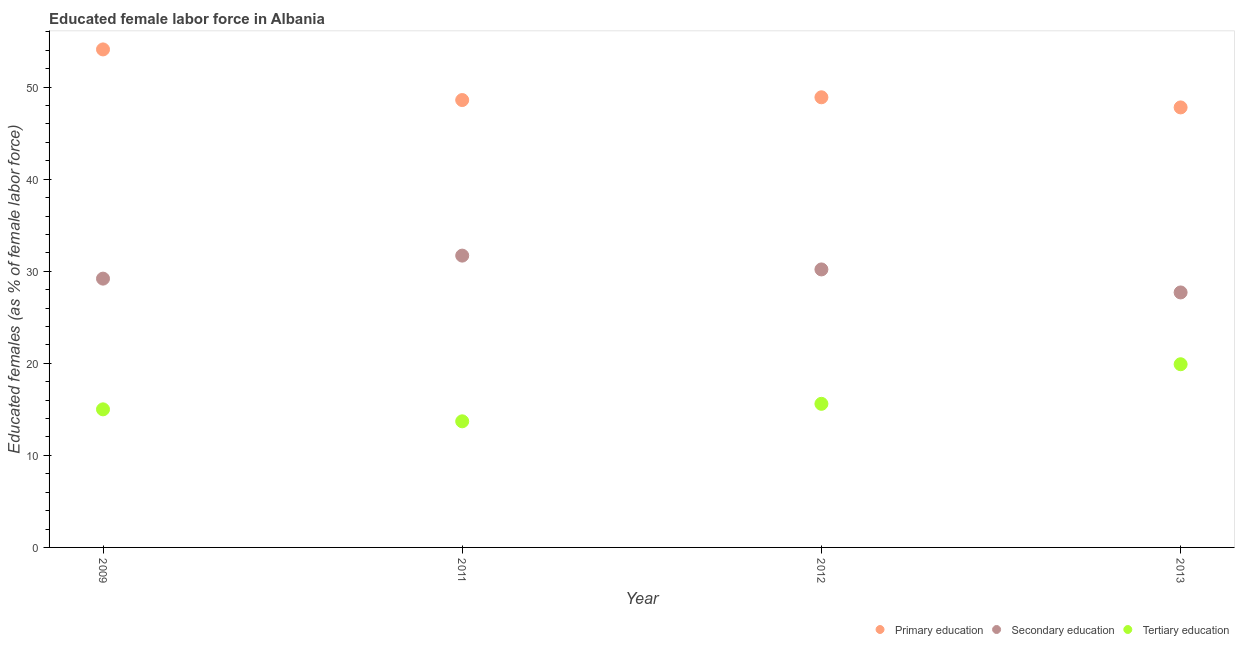What is the percentage of female labor force who received secondary education in 2012?
Provide a succinct answer. 30.2. Across all years, what is the maximum percentage of female labor force who received tertiary education?
Your response must be concise. 19.9. Across all years, what is the minimum percentage of female labor force who received primary education?
Offer a terse response. 47.8. In which year was the percentage of female labor force who received tertiary education maximum?
Your response must be concise. 2013. What is the total percentage of female labor force who received primary education in the graph?
Keep it short and to the point. 199.4. What is the difference between the percentage of female labor force who received tertiary education in 2011 and that in 2012?
Your answer should be compact. -1.9. What is the difference between the percentage of female labor force who received tertiary education in 2011 and the percentage of female labor force who received secondary education in 2009?
Ensure brevity in your answer.  -15.5. What is the average percentage of female labor force who received primary education per year?
Your response must be concise. 49.85. In the year 2013, what is the difference between the percentage of female labor force who received secondary education and percentage of female labor force who received primary education?
Offer a terse response. -20.1. What is the ratio of the percentage of female labor force who received primary education in 2009 to that in 2013?
Offer a terse response. 1.13. Is the percentage of female labor force who received secondary education in 2009 less than that in 2012?
Make the answer very short. Yes. Is the difference between the percentage of female labor force who received primary education in 2009 and 2012 greater than the difference between the percentage of female labor force who received secondary education in 2009 and 2012?
Make the answer very short. Yes. What is the difference between the highest and the lowest percentage of female labor force who received tertiary education?
Your response must be concise. 6.2. Is the sum of the percentage of female labor force who received tertiary education in 2009 and 2013 greater than the maximum percentage of female labor force who received primary education across all years?
Your answer should be very brief. No. Does the percentage of female labor force who received primary education monotonically increase over the years?
Your answer should be compact. No. Is the percentage of female labor force who received secondary education strictly greater than the percentage of female labor force who received primary education over the years?
Offer a very short reply. No. What is the difference between two consecutive major ticks on the Y-axis?
Provide a succinct answer. 10. Does the graph contain grids?
Ensure brevity in your answer.  No. Where does the legend appear in the graph?
Your answer should be very brief. Bottom right. How are the legend labels stacked?
Provide a succinct answer. Horizontal. What is the title of the graph?
Your answer should be very brief. Educated female labor force in Albania. What is the label or title of the X-axis?
Ensure brevity in your answer.  Year. What is the label or title of the Y-axis?
Your response must be concise. Educated females (as % of female labor force). What is the Educated females (as % of female labor force) of Primary education in 2009?
Offer a terse response. 54.1. What is the Educated females (as % of female labor force) in Secondary education in 2009?
Provide a succinct answer. 29.2. What is the Educated females (as % of female labor force) of Tertiary education in 2009?
Keep it short and to the point. 15. What is the Educated females (as % of female labor force) in Primary education in 2011?
Keep it short and to the point. 48.6. What is the Educated females (as % of female labor force) in Secondary education in 2011?
Offer a very short reply. 31.7. What is the Educated females (as % of female labor force) in Tertiary education in 2011?
Keep it short and to the point. 13.7. What is the Educated females (as % of female labor force) in Primary education in 2012?
Make the answer very short. 48.9. What is the Educated females (as % of female labor force) in Secondary education in 2012?
Give a very brief answer. 30.2. What is the Educated females (as % of female labor force) of Tertiary education in 2012?
Make the answer very short. 15.6. What is the Educated females (as % of female labor force) in Primary education in 2013?
Your answer should be very brief. 47.8. What is the Educated females (as % of female labor force) in Secondary education in 2013?
Ensure brevity in your answer.  27.7. What is the Educated females (as % of female labor force) in Tertiary education in 2013?
Provide a short and direct response. 19.9. Across all years, what is the maximum Educated females (as % of female labor force) in Primary education?
Your response must be concise. 54.1. Across all years, what is the maximum Educated females (as % of female labor force) of Secondary education?
Give a very brief answer. 31.7. Across all years, what is the maximum Educated females (as % of female labor force) in Tertiary education?
Make the answer very short. 19.9. Across all years, what is the minimum Educated females (as % of female labor force) of Primary education?
Make the answer very short. 47.8. Across all years, what is the minimum Educated females (as % of female labor force) in Secondary education?
Offer a very short reply. 27.7. Across all years, what is the minimum Educated females (as % of female labor force) of Tertiary education?
Make the answer very short. 13.7. What is the total Educated females (as % of female labor force) of Primary education in the graph?
Make the answer very short. 199.4. What is the total Educated females (as % of female labor force) of Secondary education in the graph?
Keep it short and to the point. 118.8. What is the total Educated females (as % of female labor force) of Tertiary education in the graph?
Make the answer very short. 64.2. What is the difference between the Educated females (as % of female labor force) of Secondary education in 2009 and that in 2011?
Your response must be concise. -2.5. What is the difference between the Educated females (as % of female labor force) in Secondary education in 2009 and that in 2012?
Offer a terse response. -1. What is the difference between the Educated females (as % of female labor force) of Secondary education in 2009 and that in 2013?
Your answer should be very brief. 1.5. What is the difference between the Educated females (as % of female labor force) of Secondary education in 2011 and that in 2013?
Give a very brief answer. 4. What is the difference between the Educated females (as % of female labor force) of Tertiary education in 2011 and that in 2013?
Your answer should be compact. -6.2. What is the difference between the Educated females (as % of female labor force) of Primary education in 2012 and that in 2013?
Give a very brief answer. 1.1. What is the difference between the Educated females (as % of female labor force) in Primary education in 2009 and the Educated females (as % of female labor force) in Secondary education in 2011?
Offer a terse response. 22.4. What is the difference between the Educated females (as % of female labor force) in Primary education in 2009 and the Educated females (as % of female labor force) in Tertiary education in 2011?
Your response must be concise. 40.4. What is the difference between the Educated females (as % of female labor force) in Secondary education in 2009 and the Educated females (as % of female labor force) in Tertiary education in 2011?
Your response must be concise. 15.5. What is the difference between the Educated females (as % of female labor force) of Primary education in 2009 and the Educated females (as % of female labor force) of Secondary education in 2012?
Make the answer very short. 23.9. What is the difference between the Educated females (as % of female labor force) in Primary education in 2009 and the Educated females (as % of female labor force) in Tertiary education in 2012?
Keep it short and to the point. 38.5. What is the difference between the Educated females (as % of female labor force) in Secondary education in 2009 and the Educated females (as % of female labor force) in Tertiary education in 2012?
Your answer should be compact. 13.6. What is the difference between the Educated females (as % of female labor force) of Primary education in 2009 and the Educated females (as % of female labor force) of Secondary education in 2013?
Keep it short and to the point. 26.4. What is the difference between the Educated females (as % of female labor force) in Primary education in 2009 and the Educated females (as % of female labor force) in Tertiary education in 2013?
Make the answer very short. 34.2. What is the difference between the Educated females (as % of female labor force) in Secondary education in 2009 and the Educated females (as % of female labor force) in Tertiary education in 2013?
Your answer should be very brief. 9.3. What is the difference between the Educated females (as % of female labor force) of Primary education in 2011 and the Educated females (as % of female labor force) of Secondary education in 2013?
Your answer should be very brief. 20.9. What is the difference between the Educated females (as % of female labor force) in Primary education in 2011 and the Educated females (as % of female labor force) in Tertiary education in 2013?
Offer a very short reply. 28.7. What is the difference between the Educated females (as % of female labor force) of Primary education in 2012 and the Educated females (as % of female labor force) of Secondary education in 2013?
Offer a terse response. 21.2. What is the difference between the Educated females (as % of female labor force) in Primary education in 2012 and the Educated females (as % of female labor force) in Tertiary education in 2013?
Provide a short and direct response. 29. What is the difference between the Educated females (as % of female labor force) in Secondary education in 2012 and the Educated females (as % of female labor force) in Tertiary education in 2013?
Your answer should be very brief. 10.3. What is the average Educated females (as % of female labor force) in Primary education per year?
Your answer should be compact. 49.85. What is the average Educated females (as % of female labor force) in Secondary education per year?
Your response must be concise. 29.7. What is the average Educated females (as % of female labor force) of Tertiary education per year?
Ensure brevity in your answer.  16.05. In the year 2009, what is the difference between the Educated females (as % of female labor force) in Primary education and Educated females (as % of female labor force) in Secondary education?
Make the answer very short. 24.9. In the year 2009, what is the difference between the Educated females (as % of female labor force) in Primary education and Educated females (as % of female labor force) in Tertiary education?
Make the answer very short. 39.1. In the year 2011, what is the difference between the Educated females (as % of female labor force) of Primary education and Educated females (as % of female labor force) of Secondary education?
Ensure brevity in your answer.  16.9. In the year 2011, what is the difference between the Educated females (as % of female labor force) of Primary education and Educated females (as % of female labor force) of Tertiary education?
Your response must be concise. 34.9. In the year 2012, what is the difference between the Educated females (as % of female labor force) in Primary education and Educated females (as % of female labor force) in Tertiary education?
Your response must be concise. 33.3. In the year 2012, what is the difference between the Educated females (as % of female labor force) in Secondary education and Educated females (as % of female labor force) in Tertiary education?
Give a very brief answer. 14.6. In the year 2013, what is the difference between the Educated females (as % of female labor force) in Primary education and Educated females (as % of female labor force) in Secondary education?
Provide a succinct answer. 20.1. In the year 2013, what is the difference between the Educated females (as % of female labor force) in Primary education and Educated females (as % of female labor force) in Tertiary education?
Provide a succinct answer. 27.9. In the year 2013, what is the difference between the Educated females (as % of female labor force) in Secondary education and Educated females (as % of female labor force) in Tertiary education?
Make the answer very short. 7.8. What is the ratio of the Educated females (as % of female labor force) of Primary education in 2009 to that in 2011?
Provide a succinct answer. 1.11. What is the ratio of the Educated females (as % of female labor force) in Secondary education in 2009 to that in 2011?
Provide a succinct answer. 0.92. What is the ratio of the Educated females (as % of female labor force) in Tertiary education in 2009 to that in 2011?
Your answer should be very brief. 1.09. What is the ratio of the Educated females (as % of female labor force) of Primary education in 2009 to that in 2012?
Offer a terse response. 1.11. What is the ratio of the Educated females (as % of female labor force) of Secondary education in 2009 to that in 2012?
Provide a short and direct response. 0.97. What is the ratio of the Educated females (as % of female labor force) of Tertiary education in 2009 to that in 2012?
Offer a very short reply. 0.96. What is the ratio of the Educated females (as % of female labor force) in Primary education in 2009 to that in 2013?
Give a very brief answer. 1.13. What is the ratio of the Educated females (as % of female labor force) in Secondary education in 2009 to that in 2013?
Offer a very short reply. 1.05. What is the ratio of the Educated females (as % of female labor force) in Tertiary education in 2009 to that in 2013?
Make the answer very short. 0.75. What is the ratio of the Educated females (as % of female labor force) in Primary education in 2011 to that in 2012?
Offer a very short reply. 0.99. What is the ratio of the Educated females (as % of female labor force) in Secondary education in 2011 to that in 2012?
Your response must be concise. 1.05. What is the ratio of the Educated females (as % of female labor force) in Tertiary education in 2011 to that in 2012?
Make the answer very short. 0.88. What is the ratio of the Educated females (as % of female labor force) in Primary education in 2011 to that in 2013?
Your answer should be compact. 1.02. What is the ratio of the Educated females (as % of female labor force) of Secondary education in 2011 to that in 2013?
Offer a terse response. 1.14. What is the ratio of the Educated females (as % of female labor force) in Tertiary education in 2011 to that in 2013?
Keep it short and to the point. 0.69. What is the ratio of the Educated females (as % of female labor force) of Secondary education in 2012 to that in 2013?
Give a very brief answer. 1.09. What is the ratio of the Educated females (as % of female labor force) in Tertiary education in 2012 to that in 2013?
Your answer should be compact. 0.78. What is the difference between the highest and the second highest Educated females (as % of female labor force) in Secondary education?
Keep it short and to the point. 1.5. What is the difference between the highest and the lowest Educated females (as % of female labor force) in Primary education?
Ensure brevity in your answer.  6.3. What is the difference between the highest and the lowest Educated females (as % of female labor force) of Secondary education?
Offer a terse response. 4. What is the difference between the highest and the lowest Educated females (as % of female labor force) of Tertiary education?
Your response must be concise. 6.2. 